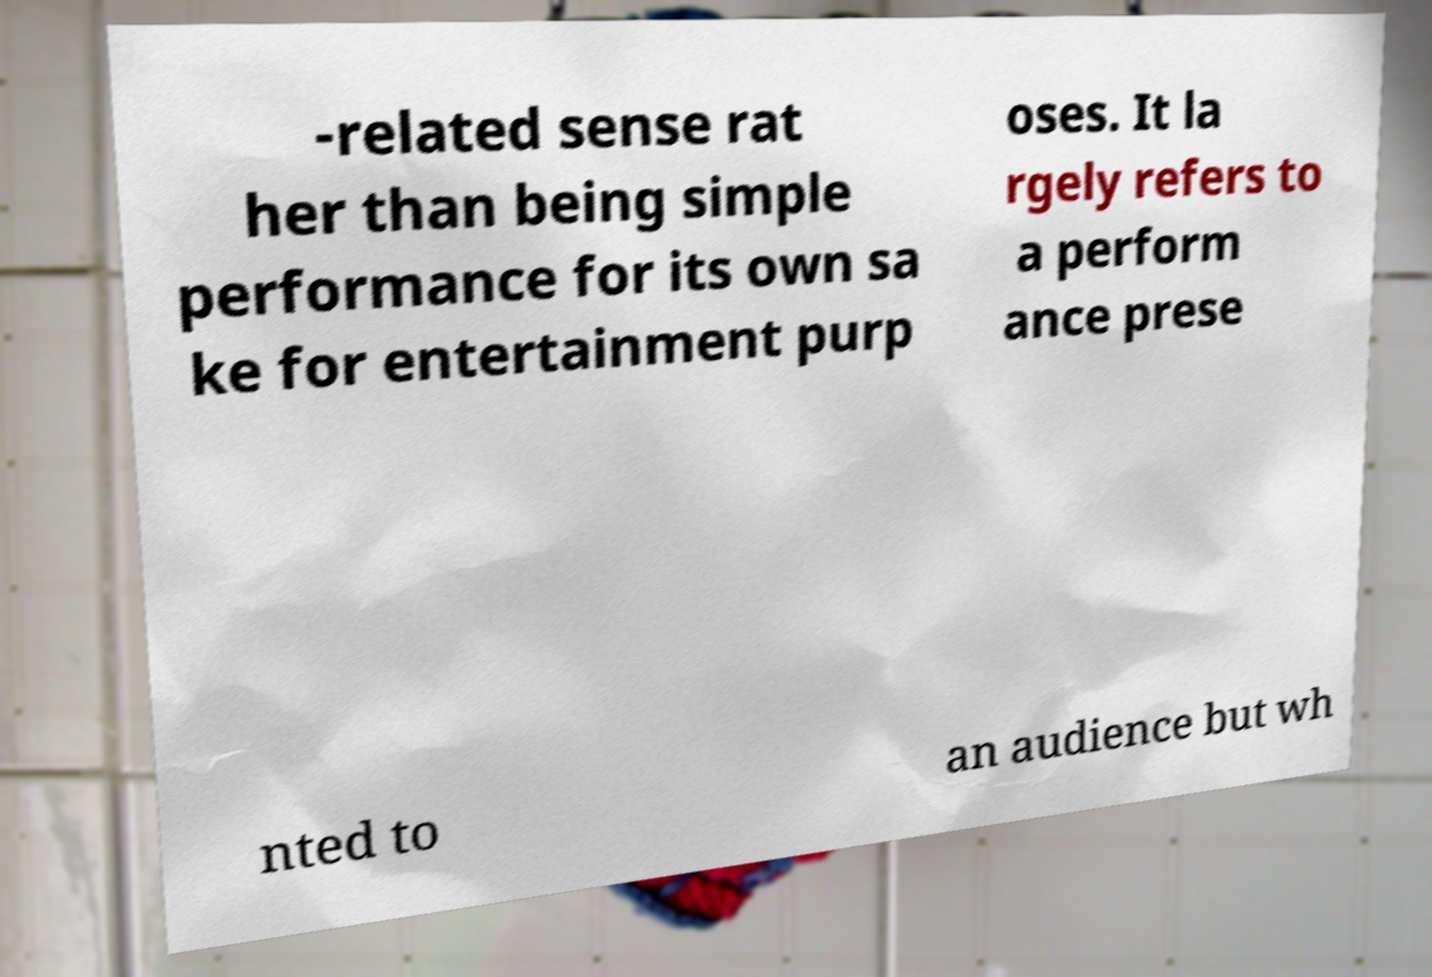For documentation purposes, I need the text within this image transcribed. Could you provide that? -related sense rat her than being simple performance for its own sa ke for entertainment purp oses. It la rgely refers to a perform ance prese nted to an audience but wh 